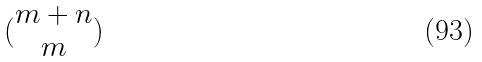Convert formula to latex. <formula><loc_0><loc_0><loc_500><loc_500>( \begin{matrix} m + n \\ m \end{matrix} )</formula> 